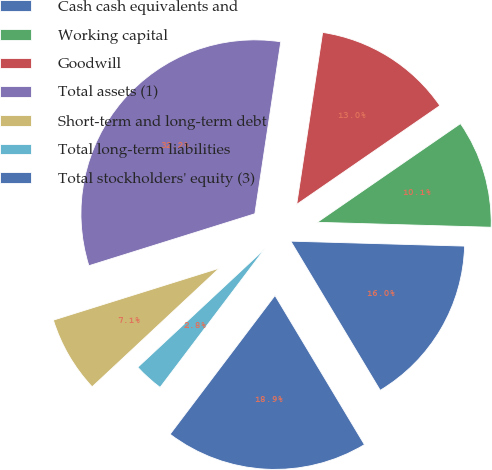Convert chart. <chart><loc_0><loc_0><loc_500><loc_500><pie_chart><fcel>Cash cash equivalents and<fcel>Working capital<fcel>Goodwill<fcel>Total assets (1)<fcel>Short-term and long-term debt<fcel>Total long-term liabilities<fcel>Total stockholders' equity (3)<nl><fcel>15.95%<fcel>10.06%<fcel>13.01%<fcel>32.21%<fcel>7.12%<fcel>2.75%<fcel>18.9%<nl></chart> 